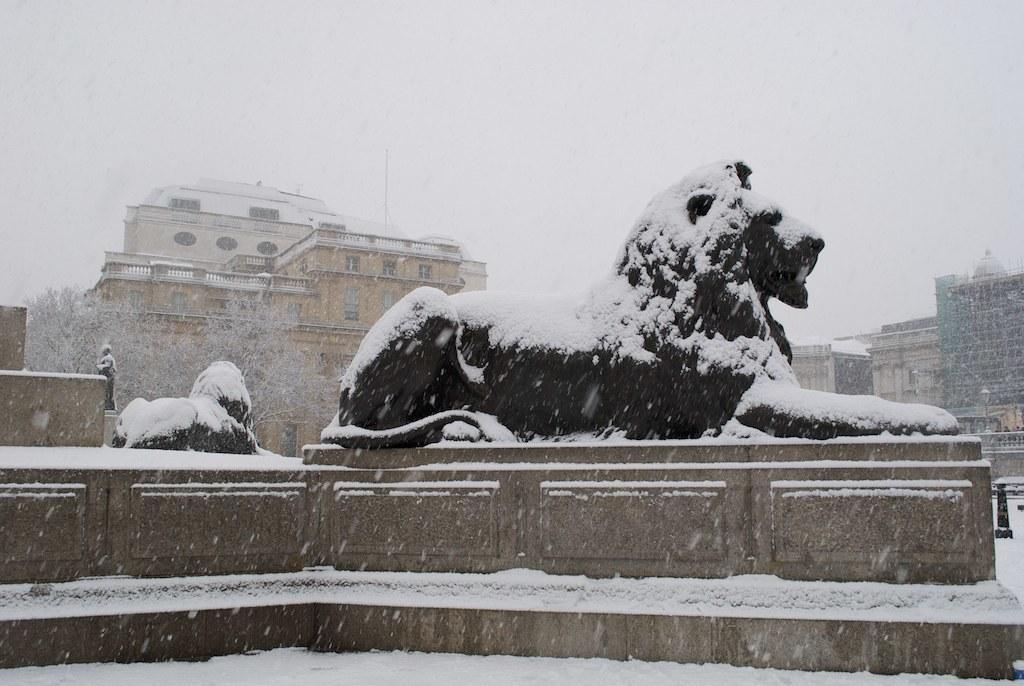Could you give a brief overview of what you see in this image? In this image we can see the statues on the stands with some snow on them. We can also see the poles, trees, some buildings and the sky which looks cloudy. 